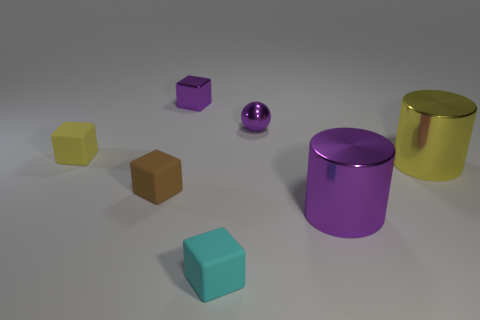Add 2 tiny purple blocks. How many objects exist? 9 Subtract all cubes. How many objects are left? 3 Subtract all yellow matte blocks. Subtract all small yellow blocks. How many objects are left? 5 Add 4 tiny purple cubes. How many tiny purple cubes are left? 5 Add 4 large gray cylinders. How many large gray cylinders exist? 4 Subtract 0 green cubes. How many objects are left? 7 